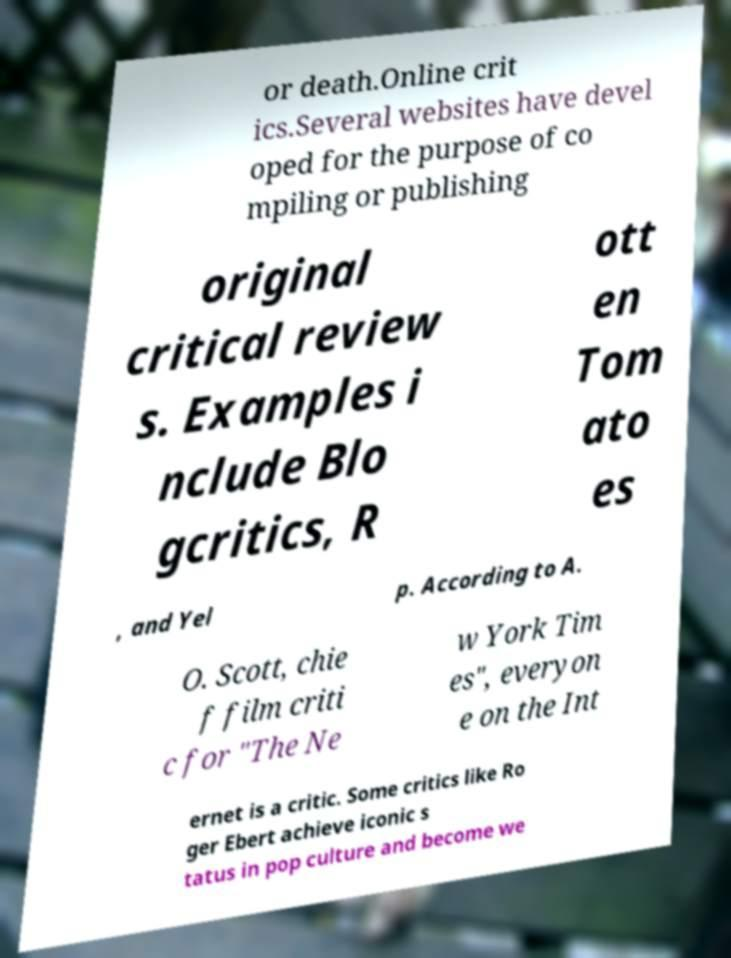What messages or text are displayed in this image? I need them in a readable, typed format. or death.Online crit ics.Several websites have devel oped for the purpose of co mpiling or publishing original critical review s. Examples i nclude Blo gcritics, R ott en Tom ato es , and Yel p. According to A. O. Scott, chie f film criti c for "The Ne w York Tim es", everyon e on the Int ernet is a critic. Some critics like Ro ger Ebert achieve iconic s tatus in pop culture and become we 